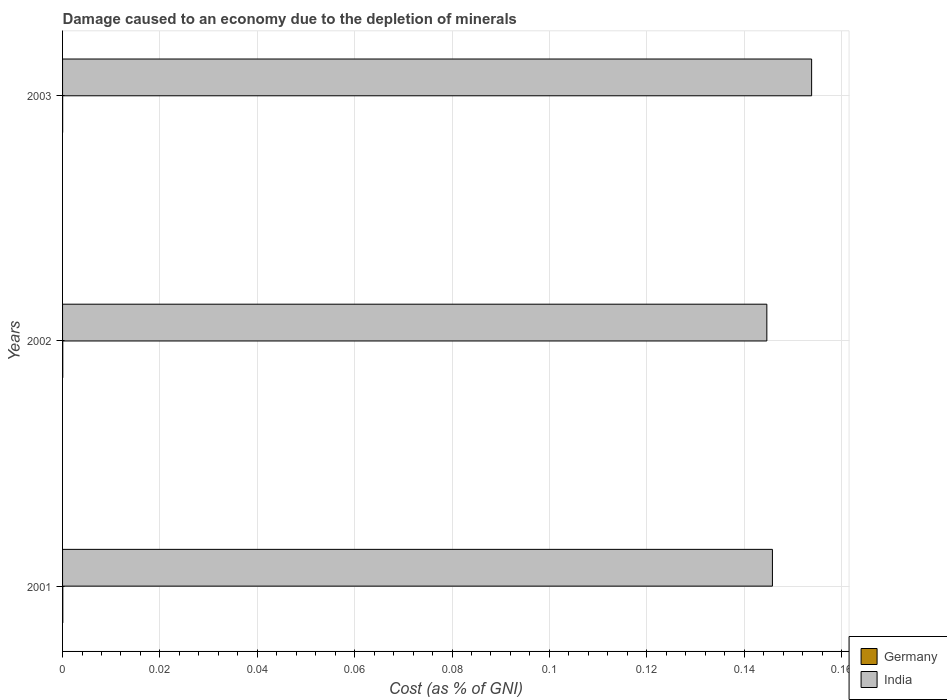How many different coloured bars are there?
Keep it short and to the point. 2. How many groups of bars are there?
Provide a short and direct response. 3. Are the number of bars per tick equal to the number of legend labels?
Make the answer very short. Yes. How many bars are there on the 1st tick from the top?
Give a very brief answer. 2. How many bars are there on the 2nd tick from the bottom?
Offer a very short reply. 2. What is the label of the 3rd group of bars from the top?
Provide a succinct answer. 2001. In how many cases, is the number of bars for a given year not equal to the number of legend labels?
Ensure brevity in your answer.  0. What is the cost of damage caused due to the depletion of minerals in Germany in 2003?
Your answer should be very brief. 1.49081092757522e-5. Across all years, what is the maximum cost of damage caused due to the depletion of minerals in Germany?
Your answer should be compact. 4.8714493152778e-5. Across all years, what is the minimum cost of damage caused due to the depletion of minerals in Germany?
Make the answer very short. 1.49081092757522e-5. In which year was the cost of damage caused due to the depletion of minerals in Germany minimum?
Provide a succinct answer. 2003. What is the total cost of damage caused due to the depletion of minerals in Germany in the graph?
Your response must be concise. 0. What is the difference between the cost of damage caused due to the depletion of minerals in Germany in 2002 and that in 2003?
Offer a very short reply. 2.6504153702399403e-5. What is the difference between the cost of damage caused due to the depletion of minerals in Germany in 2001 and the cost of damage caused due to the depletion of minerals in India in 2002?
Provide a succinct answer. -0.14. What is the average cost of damage caused due to the depletion of minerals in India per year?
Keep it short and to the point. 0.15. In the year 2002, what is the difference between the cost of damage caused due to the depletion of minerals in India and cost of damage caused due to the depletion of minerals in Germany?
Your answer should be compact. 0.14. What is the ratio of the cost of damage caused due to the depletion of minerals in India in 2001 to that in 2002?
Provide a short and direct response. 1.01. Is the cost of damage caused due to the depletion of minerals in India in 2002 less than that in 2003?
Give a very brief answer. Yes. What is the difference between the highest and the second highest cost of damage caused due to the depletion of minerals in Germany?
Ensure brevity in your answer.  7.302230174626401e-6. What is the difference between the highest and the lowest cost of damage caused due to the depletion of minerals in India?
Your answer should be very brief. 0.01. In how many years, is the cost of damage caused due to the depletion of minerals in India greater than the average cost of damage caused due to the depletion of minerals in India taken over all years?
Your answer should be very brief. 1. How many bars are there?
Give a very brief answer. 6. Are all the bars in the graph horizontal?
Keep it short and to the point. Yes. Does the graph contain any zero values?
Ensure brevity in your answer.  No. What is the title of the graph?
Offer a very short reply. Damage caused to an economy due to the depletion of minerals. Does "Puerto Rico" appear as one of the legend labels in the graph?
Offer a very short reply. No. What is the label or title of the X-axis?
Your answer should be very brief. Cost (as % of GNI). What is the Cost (as % of GNI) in Germany in 2001?
Ensure brevity in your answer.  4.8714493152778e-5. What is the Cost (as % of GNI) in India in 2001?
Offer a very short reply. 0.15. What is the Cost (as % of GNI) in Germany in 2002?
Your response must be concise. 4.14122629781516e-5. What is the Cost (as % of GNI) of India in 2002?
Provide a succinct answer. 0.14. What is the Cost (as % of GNI) of Germany in 2003?
Offer a very short reply. 1.49081092757522e-5. What is the Cost (as % of GNI) of India in 2003?
Ensure brevity in your answer.  0.15. Across all years, what is the maximum Cost (as % of GNI) in Germany?
Keep it short and to the point. 4.8714493152778e-5. Across all years, what is the maximum Cost (as % of GNI) in India?
Offer a very short reply. 0.15. Across all years, what is the minimum Cost (as % of GNI) in Germany?
Make the answer very short. 1.49081092757522e-5. Across all years, what is the minimum Cost (as % of GNI) of India?
Offer a very short reply. 0.14. What is the total Cost (as % of GNI) of India in the graph?
Offer a very short reply. 0.44. What is the difference between the Cost (as % of GNI) in Germany in 2001 and that in 2002?
Keep it short and to the point. 0. What is the difference between the Cost (as % of GNI) in India in 2001 and that in 2002?
Your response must be concise. 0. What is the difference between the Cost (as % of GNI) of India in 2001 and that in 2003?
Keep it short and to the point. -0.01. What is the difference between the Cost (as % of GNI) of Germany in 2002 and that in 2003?
Your answer should be compact. 0. What is the difference between the Cost (as % of GNI) of India in 2002 and that in 2003?
Provide a succinct answer. -0.01. What is the difference between the Cost (as % of GNI) of Germany in 2001 and the Cost (as % of GNI) of India in 2002?
Provide a short and direct response. -0.14. What is the difference between the Cost (as % of GNI) in Germany in 2001 and the Cost (as % of GNI) in India in 2003?
Your response must be concise. -0.15. What is the difference between the Cost (as % of GNI) of Germany in 2002 and the Cost (as % of GNI) of India in 2003?
Your answer should be very brief. -0.15. What is the average Cost (as % of GNI) of Germany per year?
Make the answer very short. 0. What is the average Cost (as % of GNI) in India per year?
Give a very brief answer. 0.15. In the year 2001, what is the difference between the Cost (as % of GNI) of Germany and Cost (as % of GNI) of India?
Offer a terse response. -0.15. In the year 2002, what is the difference between the Cost (as % of GNI) in Germany and Cost (as % of GNI) in India?
Offer a very short reply. -0.14. In the year 2003, what is the difference between the Cost (as % of GNI) of Germany and Cost (as % of GNI) of India?
Your response must be concise. -0.15. What is the ratio of the Cost (as % of GNI) of Germany in 2001 to that in 2002?
Keep it short and to the point. 1.18. What is the ratio of the Cost (as % of GNI) in India in 2001 to that in 2002?
Your answer should be very brief. 1.01. What is the ratio of the Cost (as % of GNI) in Germany in 2001 to that in 2003?
Make the answer very short. 3.27. What is the ratio of the Cost (as % of GNI) of India in 2001 to that in 2003?
Keep it short and to the point. 0.95. What is the ratio of the Cost (as % of GNI) in Germany in 2002 to that in 2003?
Make the answer very short. 2.78. What is the ratio of the Cost (as % of GNI) of India in 2002 to that in 2003?
Give a very brief answer. 0.94. What is the difference between the highest and the second highest Cost (as % of GNI) of Germany?
Ensure brevity in your answer.  0. What is the difference between the highest and the second highest Cost (as % of GNI) in India?
Your response must be concise. 0.01. What is the difference between the highest and the lowest Cost (as % of GNI) of India?
Provide a short and direct response. 0.01. 